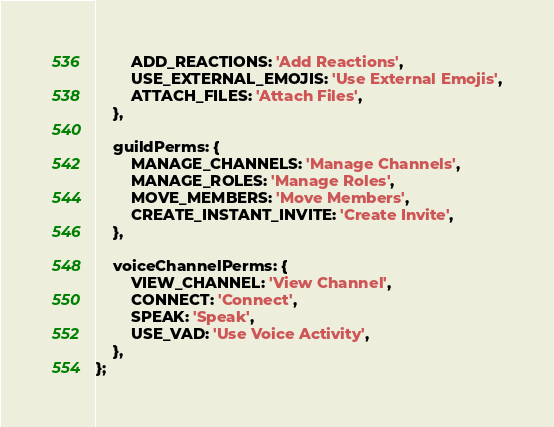Convert code to text. <code><loc_0><loc_0><loc_500><loc_500><_JavaScript_>        ADD_REACTIONS: 'Add Reactions',
        USE_EXTERNAL_EMOJIS: 'Use External Emojis',
        ATTACH_FILES: 'Attach Files',
    },

    guildPerms: {
        MANAGE_CHANNELS: 'Manage Channels',
        MANAGE_ROLES: 'Manage Roles',
        MOVE_MEMBERS: 'Move Members',
        CREATE_INSTANT_INVITE: 'Create Invite',
    },

    voiceChannelPerms: {
        VIEW_CHANNEL: 'View Channel',
        CONNECT: 'Connect',
        SPEAK: 'Speak',
        USE_VAD: 'Use Voice Activity',
    },
};</code> 